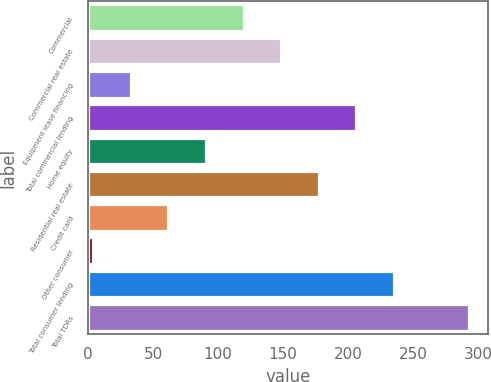<chart> <loc_0><loc_0><loc_500><loc_500><bar_chart><fcel>Commercial<fcel>Commercial real estate<fcel>Equipment lease financing<fcel>Total commercial lending<fcel>Home equity<fcel>Residential real estate<fcel>Credit card<fcel>Other consumer<fcel>Total consumer lending<fcel>Total TDRs<nl><fcel>119.6<fcel>148.5<fcel>32.9<fcel>206.3<fcel>90.7<fcel>177.4<fcel>61.8<fcel>4<fcel>235.2<fcel>293<nl></chart> 